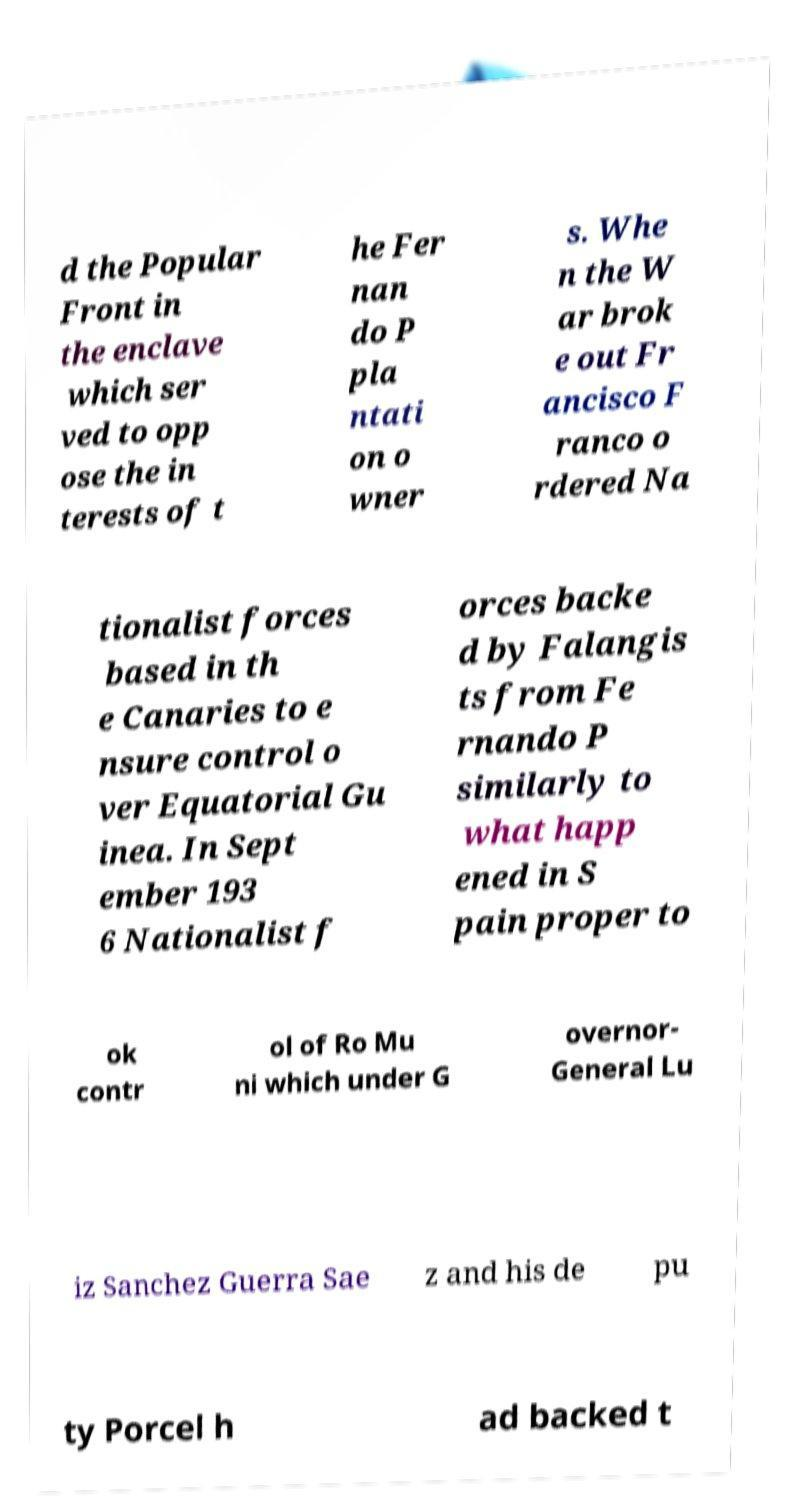What messages or text are displayed in this image? I need them in a readable, typed format. d the Popular Front in the enclave which ser ved to opp ose the in terests of t he Fer nan do P pla ntati on o wner s. Whe n the W ar brok e out Fr ancisco F ranco o rdered Na tionalist forces based in th e Canaries to e nsure control o ver Equatorial Gu inea. In Sept ember 193 6 Nationalist f orces backe d by Falangis ts from Fe rnando P similarly to what happ ened in S pain proper to ok contr ol of Ro Mu ni which under G overnor- General Lu iz Sanchez Guerra Sae z and his de pu ty Porcel h ad backed t 